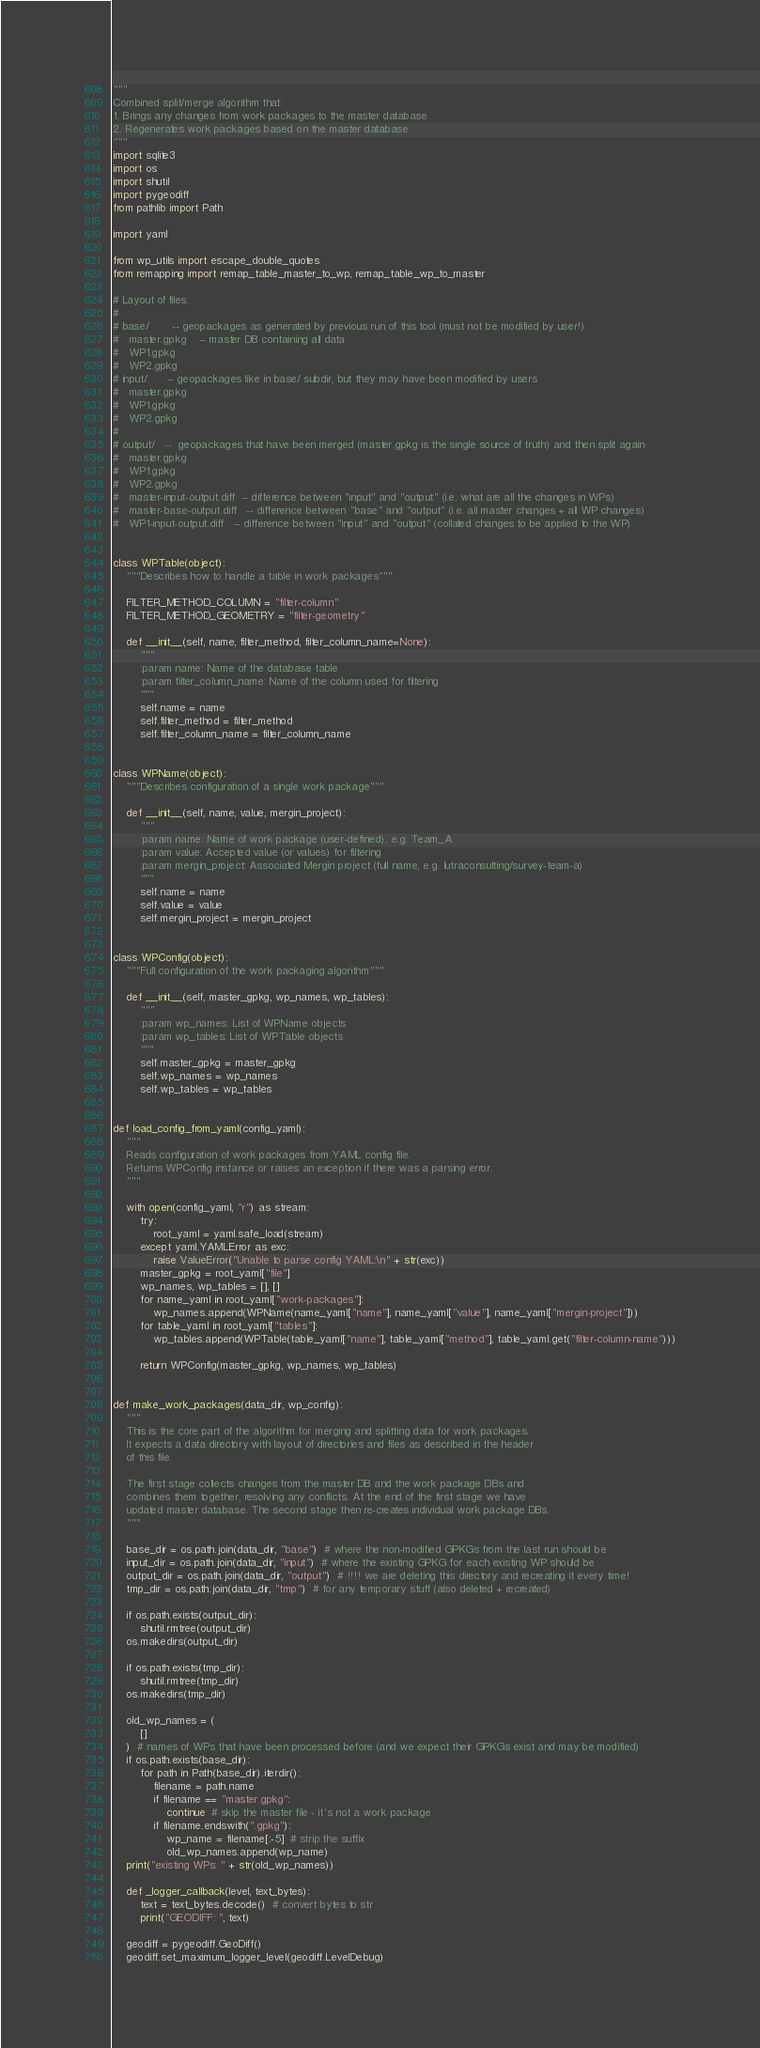<code> <loc_0><loc_0><loc_500><loc_500><_Python_>"""
Combined split/merge algorithm that:
1. Brings any changes from work packages to the master database
2. Regenerates work packages based on the master database
"""
import sqlite3
import os
import shutil
import pygeodiff
from pathlib import Path

import yaml

from wp_utils import escape_double_quotes
from remapping import remap_table_master_to_wp, remap_table_wp_to_master

# Layout of files:
#
# base/       -- geopackages as generated by previous run of this tool (must not be modified by user!)
#   master.gpkg    -- master DB containing all data
#   WP1.gpkg
#   WP2.gpkg
# input/      -- geopackages like in base/ subdir, but they may have been modified by users
#   master.gpkg
#   WP1.gpkg
#   WP2.gpkg
#
# output/   --  geopackages that have been merged (master.gpkg is the single source of truth) and then split again
#   master.gpkg
#   WP1.gpkg
#   WP2.gpkg
#   master-input-output.diff  -- difference between "input" and "output" (i.e. what are all the changes in WPs)
#   master-base-output.diff   -- difference between "base" and "output" (i.e. all master changes + all WP changes)
#   WP1-input-output.diff   -- difference between "input" and "output" (collated changes to be applied to the WP)


class WPTable(object):
    """Describes how to handle a table in work packages"""

    FILTER_METHOD_COLUMN = "filter-column"
    FILTER_METHOD_GEOMETRY = "filter-geometry"

    def __init__(self, name, filter_method, filter_column_name=None):
        """
        :param name: Name of the database table
        :param filter_column_name: Name of the column used for filtering
        """
        self.name = name
        self.filter_method = filter_method
        self.filter_column_name = filter_column_name


class WPName(object):
    """Describes configuration of a single work package"""

    def __init__(self, name, value, mergin_project):
        """
        :param name: Name of work package (user-defined), e.g. Team_A
        :param value: Accepted value (or values) for filtering
        :param mergin_project: Associated Mergin project (full name, e.g. lutraconsulting/survey-team-a)
        """
        self.name = name
        self.value = value
        self.mergin_project = mergin_project


class WPConfig(object):
    """Full configuration of the work packaging algorithm"""

    def __init__(self, master_gpkg, wp_names, wp_tables):
        """
        :param wp_names: List of WPName objects
        :param wp_tables: List of WPTable objects
        """
        self.master_gpkg = master_gpkg
        self.wp_names = wp_names
        self.wp_tables = wp_tables


def load_config_from_yaml(config_yaml):
    """
    Reads configuration of work packages from YAML config file.
    Returns WPConfig instance or raises an exception if there was a parsing error.
    """

    with open(config_yaml, "r") as stream:
        try:
            root_yaml = yaml.safe_load(stream)
        except yaml.YAMLError as exc:
            raise ValueError("Unable to parse config YAML:\n" + str(exc))
        master_gpkg = root_yaml["file"]
        wp_names, wp_tables = [], []
        for name_yaml in root_yaml["work-packages"]:
            wp_names.append(WPName(name_yaml["name"], name_yaml["value"], name_yaml["mergin-project"]))
        for table_yaml in root_yaml["tables"]:
            wp_tables.append(WPTable(table_yaml["name"], table_yaml["method"], table_yaml.get("filter-column-name")))

        return WPConfig(master_gpkg, wp_names, wp_tables)


def make_work_packages(data_dir, wp_config):
    """
    This is the core part of the algorithm for merging and splitting data for work packages.
    It expects a data directory with layout of directories and files as described in the header
    of this file.

    The first stage collects changes from the master DB and the work package DBs and
    combines them together, resolving any conflicts. At the end of the first stage we have
    updated master database. The second stage then re-creates individual work package DBs.
    """

    base_dir = os.path.join(data_dir, "base")  # where the non-modified GPKGs from the last run should be
    input_dir = os.path.join(data_dir, "input")  # where the existing GPKG for each existing WP should be
    output_dir = os.path.join(data_dir, "output")  # !!!! we are deleting this directory and recreating it every time!
    tmp_dir = os.path.join(data_dir, "tmp")  # for any temporary stuff (also deleted + recreated)

    if os.path.exists(output_dir):
        shutil.rmtree(output_dir)
    os.makedirs(output_dir)

    if os.path.exists(tmp_dir):
        shutil.rmtree(tmp_dir)
    os.makedirs(tmp_dir)

    old_wp_names = (
        []
    )  # names of WPs that have been processed before (and we expect their GPKGs exist and may be modified)
    if os.path.exists(base_dir):
        for path in Path(base_dir).iterdir():
            filename = path.name
            if filename == "master.gpkg":
                continue  # skip the master file - it's not a work package
            if filename.endswith(".gpkg"):
                wp_name = filename[:-5]  # strip the suffix
                old_wp_names.append(wp_name)
    print("existing WPs: " + str(old_wp_names))

    def _logger_callback(level, text_bytes):
        text = text_bytes.decode()  # convert bytes to str
        print("GEODIFF: ", text)

    geodiff = pygeodiff.GeoDiff()
    geodiff.set_maximum_logger_level(geodiff.LevelDebug)</code> 